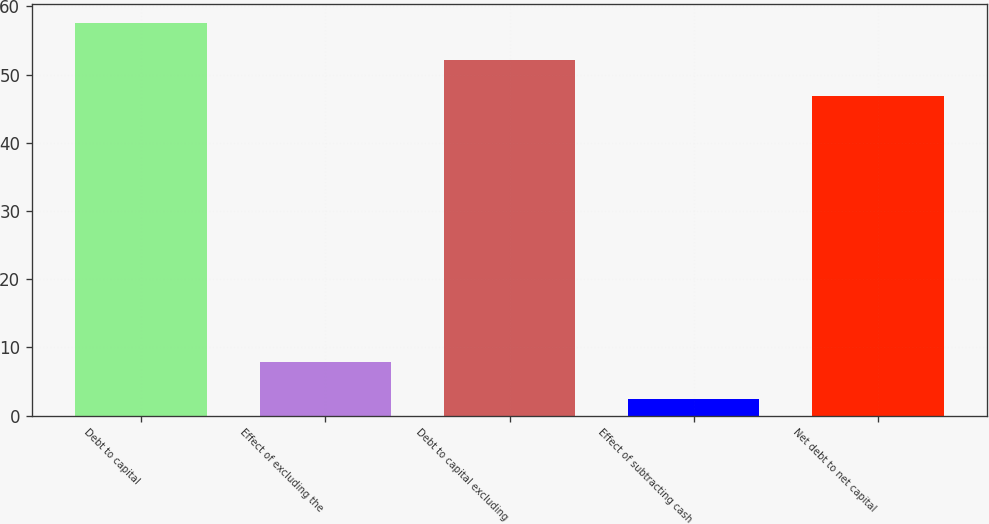<chart> <loc_0><loc_0><loc_500><loc_500><bar_chart><fcel>Debt to capital<fcel>Effect of excluding the<fcel>Debt to capital excluding<fcel>Effect of subtracting cash<fcel>Net debt to net capital<nl><fcel>57.54<fcel>7.82<fcel>52.22<fcel>2.5<fcel>46.9<nl></chart> 